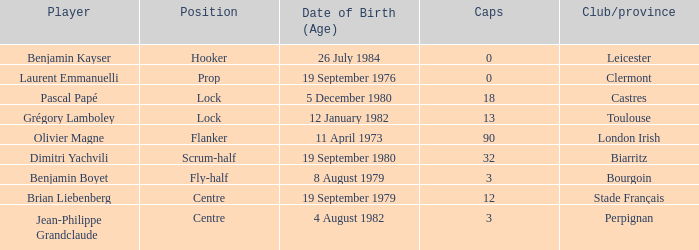What is the celebration day of 32-sized caps? 19 September 1980. 